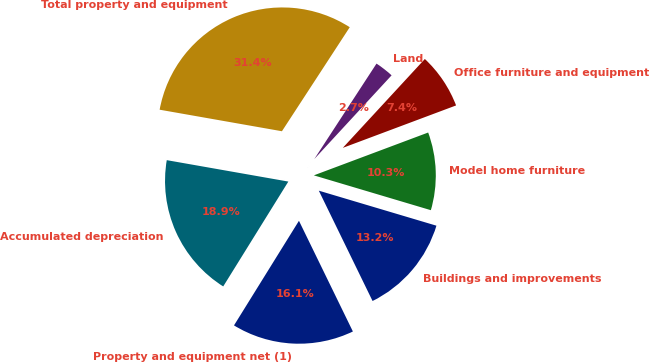Convert chart. <chart><loc_0><loc_0><loc_500><loc_500><pie_chart><fcel>Buildings and improvements<fcel>Model home furniture<fcel>Office furniture and equipment<fcel>Land<fcel>Total property and equipment<fcel>Accumulated depreciation<fcel>Property and equipment net (1)<nl><fcel>13.18%<fcel>10.31%<fcel>7.43%<fcel>2.67%<fcel>31.42%<fcel>18.93%<fcel>16.06%<nl></chart> 